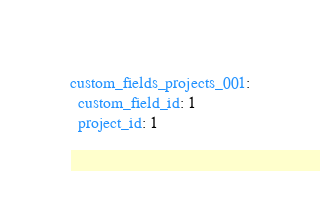<code> <loc_0><loc_0><loc_500><loc_500><_YAML_>custom_fields_projects_001:
  custom_field_id: 1
  project_id: 1</code> 